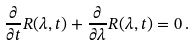<formula> <loc_0><loc_0><loc_500><loc_500>\frac { \partial } { \partial t } R ( \lambda , t ) + \frac { \partial } { \partial \lambda } R ( \lambda , t ) = 0 \, .</formula> 